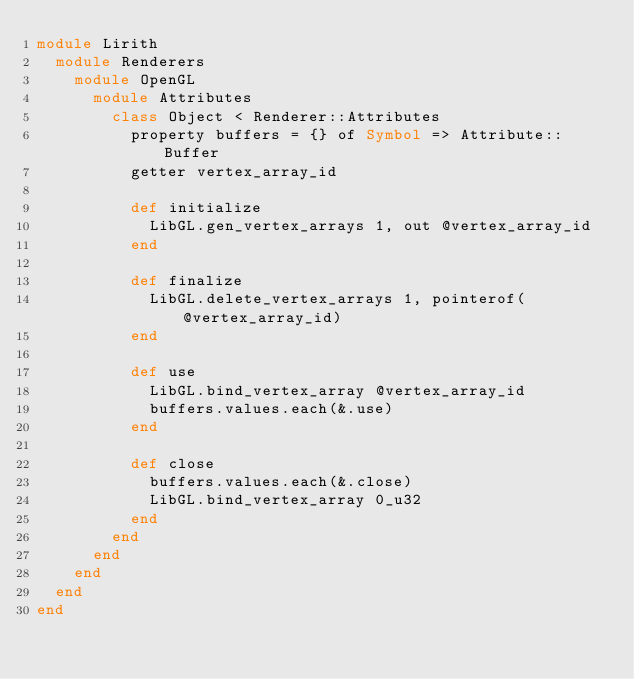Convert code to text. <code><loc_0><loc_0><loc_500><loc_500><_Crystal_>module Lirith
  module Renderers
    module OpenGL
      module Attributes
        class Object < Renderer::Attributes
          property buffers = {} of Symbol => Attribute::Buffer
          getter vertex_array_id

          def initialize
            LibGL.gen_vertex_arrays 1, out @vertex_array_id
          end

          def finalize
            LibGL.delete_vertex_arrays 1, pointerof(@vertex_array_id)
          end

          def use
            LibGL.bind_vertex_array @vertex_array_id
            buffers.values.each(&.use)
          end

          def close
            buffers.values.each(&.close)
            LibGL.bind_vertex_array 0_u32
          end
        end
      end
    end
  end
end
</code> 